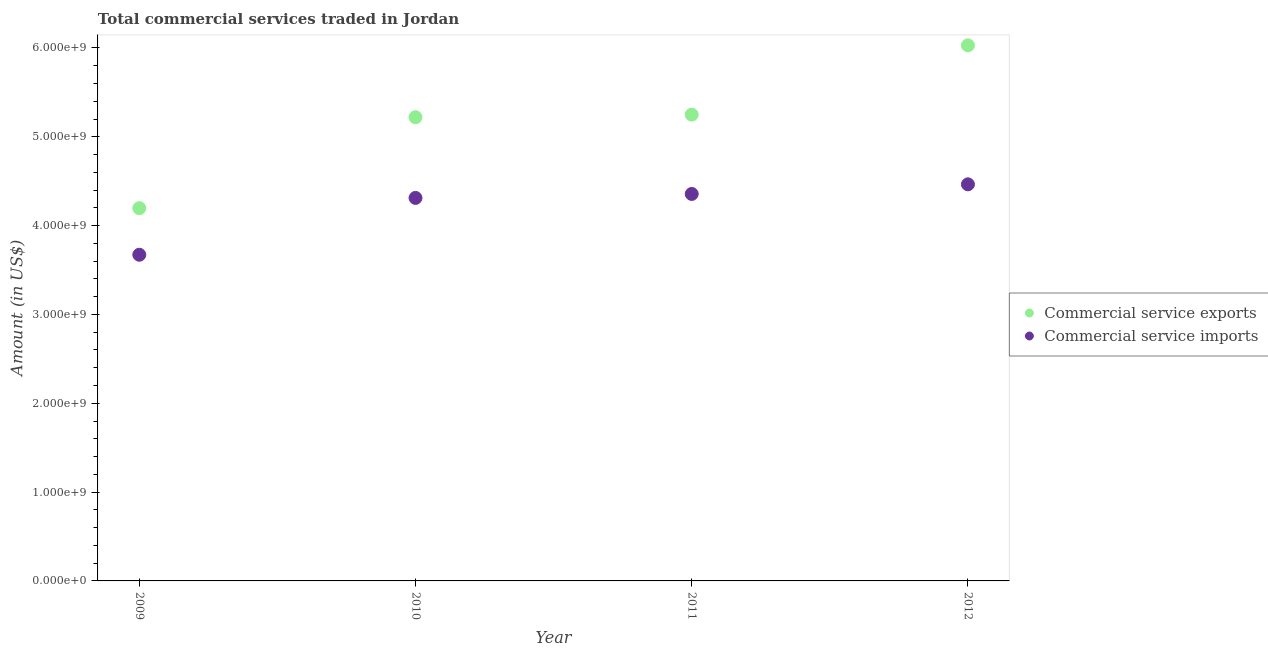What is the amount of commercial service imports in 2012?
Offer a very short reply. 4.47e+09. Across all years, what is the maximum amount of commercial service exports?
Provide a succinct answer. 6.03e+09. Across all years, what is the minimum amount of commercial service imports?
Make the answer very short. 3.67e+09. In which year was the amount of commercial service exports maximum?
Keep it short and to the point. 2012. What is the total amount of commercial service imports in the graph?
Ensure brevity in your answer.  1.68e+1. What is the difference between the amount of commercial service exports in 2011 and that in 2012?
Offer a terse response. -7.80e+08. What is the difference between the amount of commercial service imports in 2011 and the amount of commercial service exports in 2009?
Your response must be concise. 1.60e+08. What is the average amount of commercial service imports per year?
Offer a very short reply. 4.20e+09. In the year 2009, what is the difference between the amount of commercial service exports and amount of commercial service imports?
Offer a very short reply. 5.24e+08. In how many years, is the amount of commercial service exports greater than 3200000000 US$?
Ensure brevity in your answer.  4. What is the ratio of the amount of commercial service imports in 2010 to that in 2011?
Give a very brief answer. 0.99. Is the amount of commercial service exports in 2011 less than that in 2012?
Provide a short and direct response. Yes. Is the difference between the amount of commercial service imports in 2009 and 2012 greater than the difference between the amount of commercial service exports in 2009 and 2012?
Give a very brief answer. Yes. What is the difference between the highest and the second highest amount of commercial service imports?
Your response must be concise. 1.08e+08. What is the difference between the highest and the lowest amount of commercial service imports?
Keep it short and to the point. 7.93e+08. Does the amount of commercial service imports monotonically increase over the years?
Give a very brief answer. Yes. Is the amount of commercial service exports strictly less than the amount of commercial service imports over the years?
Ensure brevity in your answer.  No. How many years are there in the graph?
Offer a very short reply. 4. What is the difference between two consecutive major ticks on the Y-axis?
Give a very brief answer. 1.00e+09. How many legend labels are there?
Offer a very short reply. 2. What is the title of the graph?
Your answer should be compact. Total commercial services traded in Jordan. Does "Number of departures" appear as one of the legend labels in the graph?
Keep it short and to the point. No. What is the label or title of the X-axis?
Give a very brief answer. Year. What is the Amount (in US$) of Commercial service exports in 2009?
Your answer should be very brief. 4.20e+09. What is the Amount (in US$) in Commercial service imports in 2009?
Your response must be concise. 3.67e+09. What is the Amount (in US$) in Commercial service exports in 2010?
Ensure brevity in your answer.  5.22e+09. What is the Amount (in US$) of Commercial service imports in 2010?
Your answer should be very brief. 4.31e+09. What is the Amount (in US$) of Commercial service exports in 2011?
Your response must be concise. 5.25e+09. What is the Amount (in US$) in Commercial service imports in 2011?
Make the answer very short. 4.36e+09. What is the Amount (in US$) in Commercial service exports in 2012?
Your answer should be compact. 6.03e+09. What is the Amount (in US$) in Commercial service imports in 2012?
Offer a very short reply. 4.47e+09. Across all years, what is the maximum Amount (in US$) of Commercial service exports?
Offer a very short reply. 6.03e+09. Across all years, what is the maximum Amount (in US$) in Commercial service imports?
Ensure brevity in your answer.  4.47e+09. Across all years, what is the minimum Amount (in US$) of Commercial service exports?
Ensure brevity in your answer.  4.20e+09. Across all years, what is the minimum Amount (in US$) of Commercial service imports?
Your answer should be very brief. 3.67e+09. What is the total Amount (in US$) of Commercial service exports in the graph?
Ensure brevity in your answer.  2.07e+1. What is the total Amount (in US$) of Commercial service imports in the graph?
Ensure brevity in your answer.  1.68e+1. What is the difference between the Amount (in US$) in Commercial service exports in 2009 and that in 2010?
Keep it short and to the point. -1.02e+09. What is the difference between the Amount (in US$) in Commercial service imports in 2009 and that in 2010?
Provide a succinct answer. -6.40e+08. What is the difference between the Amount (in US$) in Commercial service exports in 2009 and that in 2011?
Ensure brevity in your answer.  -1.05e+09. What is the difference between the Amount (in US$) in Commercial service imports in 2009 and that in 2011?
Give a very brief answer. -6.85e+08. What is the difference between the Amount (in US$) of Commercial service exports in 2009 and that in 2012?
Provide a short and direct response. -1.83e+09. What is the difference between the Amount (in US$) in Commercial service imports in 2009 and that in 2012?
Your response must be concise. -7.93e+08. What is the difference between the Amount (in US$) in Commercial service exports in 2010 and that in 2011?
Ensure brevity in your answer.  -2.94e+07. What is the difference between the Amount (in US$) in Commercial service imports in 2010 and that in 2011?
Keep it short and to the point. -4.46e+07. What is the difference between the Amount (in US$) in Commercial service exports in 2010 and that in 2012?
Offer a terse response. -8.09e+08. What is the difference between the Amount (in US$) of Commercial service imports in 2010 and that in 2012?
Ensure brevity in your answer.  -1.53e+08. What is the difference between the Amount (in US$) of Commercial service exports in 2011 and that in 2012?
Give a very brief answer. -7.80e+08. What is the difference between the Amount (in US$) of Commercial service imports in 2011 and that in 2012?
Provide a short and direct response. -1.08e+08. What is the difference between the Amount (in US$) of Commercial service exports in 2009 and the Amount (in US$) of Commercial service imports in 2010?
Ensure brevity in your answer.  -1.15e+08. What is the difference between the Amount (in US$) in Commercial service exports in 2009 and the Amount (in US$) in Commercial service imports in 2011?
Give a very brief answer. -1.60e+08. What is the difference between the Amount (in US$) in Commercial service exports in 2009 and the Amount (in US$) in Commercial service imports in 2012?
Give a very brief answer. -2.68e+08. What is the difference between the Amount (in US$) of Commercial service exports in 2010 and the Amount (in US$) of Commercial service imports in 2011?
Your response must be concise. 8.64e+08. What is the difference between the Amount (in US$) in Commercial service exports in 2010 and the Amount (in US$) in Commercial service imports in 2012?
Keep it short and to the point. 7.55e+08. What is the difference between the Amount (in US$) of Commercial service exports in 2011 and the Amount (in US$) of Commercial service imports in 2012?
Your answer should be very brief. 7.85e+08. What is the average Amount (in US$) of Commercial service exports per year?
Your answer should be compact. 5.17e+09. What is the average Amount (in US$) of Commercial service imports per year?
Your answer should be very brief. 4.20e+09. In the year 2009, what is the difference between the Amount (in US$) of Commercial service exports and Amount (in US$) of Commercial service imports?
Your answer should be very brief. 5.24e+08. In the year 2010, what is the difference between the Amount (in US$) in Commercial service exports and Amount (in US$) in Commercial service imports?
Your answer should be very brief. 9.08e+08. In the year 2011, what is the difference between the Amount (in US$) of Commercial service exports and Amount (in US$) of Commercial service imports?
Ensure brevity in your answer.  8.93e+08. In the year 2012, what is the difference between the Amount (in US$) in Commercial service exports and Amount (in US$) in Commercial service imports?
Make the answer very short. 1.56e+09. What is the ratio of the Amount (in US$) of Commercial service exports in 2009 to that in 2010?
Make the answer very short. 0.8. What is the ratio of the Amount (in US$) of Commercial service imports in 2009 to that in 2010?
Keep it short and to the point. 0.85. What is the ratio of the Amount (in US$) of Commercial service exports in 2009 to that in 2011?
Make the answer very short. 0.8. What is the ratio of the Amount (in US$) in Commercial service imports in 2009 to that in 2011?
Ensure brevity in your answer.  0.84. What is the ratio of the Amount (in US$) in Commercial service exports in 2009 to that in 2012?
Keep it short and to the point. 0.7. What is the ratio of the Amount (in US$) in Commercial service imports in 2009 to that in 2012?
Give a very brief answer. 0.82. What is the ratio of the Amount (in US$) in Commercial service exports in 2010 to that in 2012?
Your response must be concise. 0.87. What is the ratio of the Amount (in US$) of Commercial service imports in 2010 to that in 2012?
Provide a succinct answer. 0.97. What is the ratio of the Amount (in US$) of Commercial service exports in 2011 to that in 2012?
Ensure brevity in your answer.  0.87. What is the ratio of the Amount (in US$) in Commercial service imports in 2011 to that in 2012?
Your answer should be compact. 0.98. What is the difference between the highest and the second highest Amount (in US$) in Commercial service exports?
Ensure brevity in your answer.  7.80e+08. What is the difference between the highest and the second highest Amount (in US$) in Commercial service imports?
Your answer should be very brief. 1.08e+08. What is the difference between the highest and the lowest Amount (in US$) of Commercial service exports?
Your response must be concise. 1.83e+09. What is the difference between the highest and the lowest Amount (in US$) in Commercial service imports?
Keep it short and to the point. 7.93e+08. 